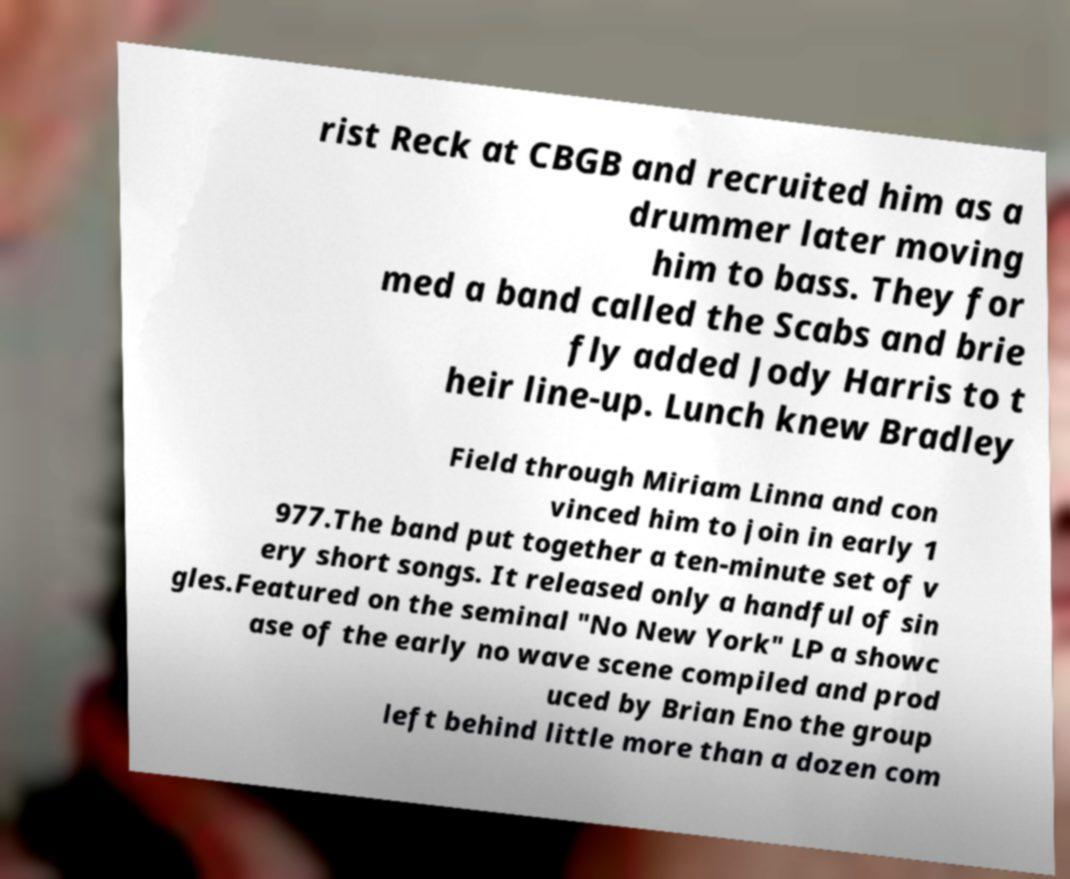I need the written content from this picture converted into text. Can you do that? rist Reck at CBGB and recruited him as a drummer later moving him to bass. They for med a band called the Scabs and brie fly added Jody Harris to t heir line-up. Lunch knew Bradley Field through Miriam Linna and con vinced him to join in early 1 977.The band put together a ten-minute set of v ery short songs. It released only a handful of sin gles.Featured on the seminal "No New York" LP a showc ase of the early no wave scene compiled and prod uced by Brian Eno the group left behind little more than a dozen com 